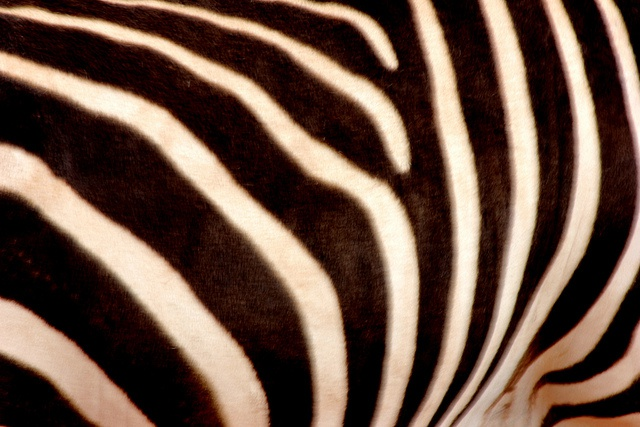Describe the objects in this image and their specific colors. I can see a zebra in black, beige, tan, and maroon tones in this image. 